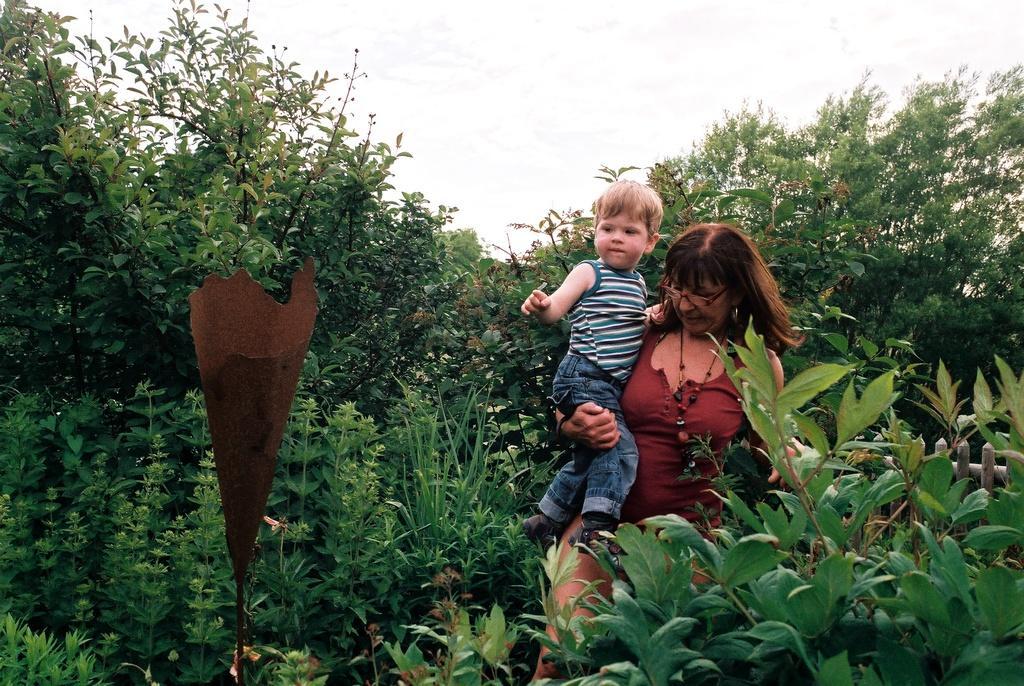Please provide a concise description of this image. In this image I can see two persons, few plants in green color. In the background the sky is in white color. 